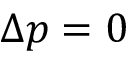<formula> <loc_0><loc_0><loc_500><loc_500>\Delta p = 0</formula> 